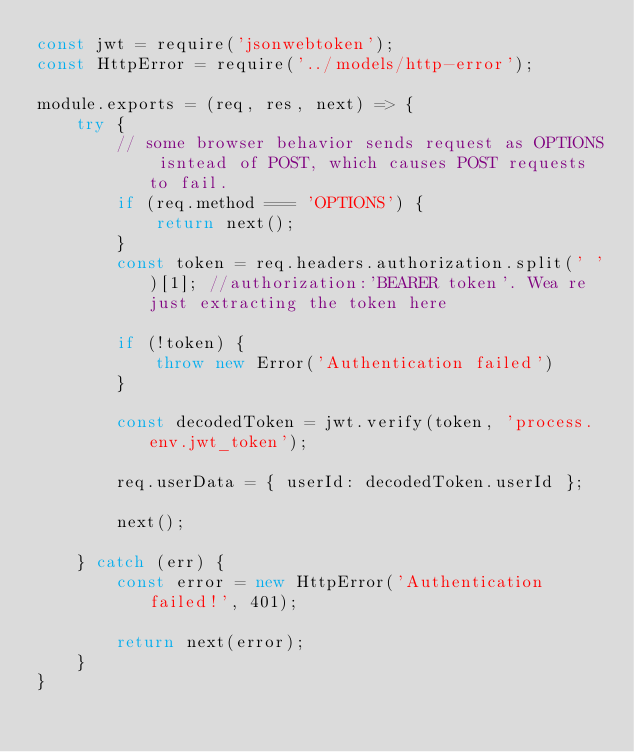Convert code to text. <code><loc_0><loc_0><loc_500><loc_500><_JavaScript_>const jwt = require('jsonwebtoken');
const HttpError = require('../models/http-error');

module.exports = (req, res, next) => {
    try {
        // some browser behavior sends request as OPTIONS isntead of POST, which causes POST requests to fail.
        if (req.method === 'OPTIONS') {
            return next();
        }
        const token = req.headers.authorization.split(' ')[1]; //authorization:'BEARER token'. Wea re just extracting the token here

        if (!token) {
            throw new Error('Authentication failed')
        }

        const decodedToken = jwt.verify(token, 'process.env.jwt_token');

        req.userData = { userId: decodedToken.userId };

        next();

    } catch (err) {
        const error = new HttpError('Authentication failed!', 401);

        return next(error);
    }
}</code> 